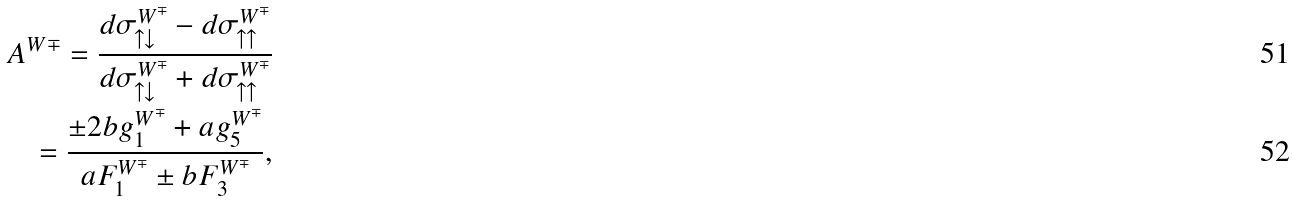<formula> <loc_0><loc_0><loc_500><loc_500>A ^ { W \mp } = \frac { d \sigma ^ { W ^ { \mp } } _ { \uparrow \downarrow } - d \sigma ^ { W ^ { \mp } } _ { \uparrow \uparrow } } { d \sigma ^ { W ^ { \mp } } _ { \uparrow \downarrow } + d \sigma ^ { W ^ { \mp } } _ { \uparrow \uparrow } } \\ = \frac { \pm 2 b g ^ { W ^ { \mp } } _ { 1 } + a g ^ { W ^ { \mp } } _ { 5 } } { a F ^ { W ^ { \mp } } _ { 1 } \pm b F ^ { W ^ { \mp } } _ { 3 } } ,</formula> 